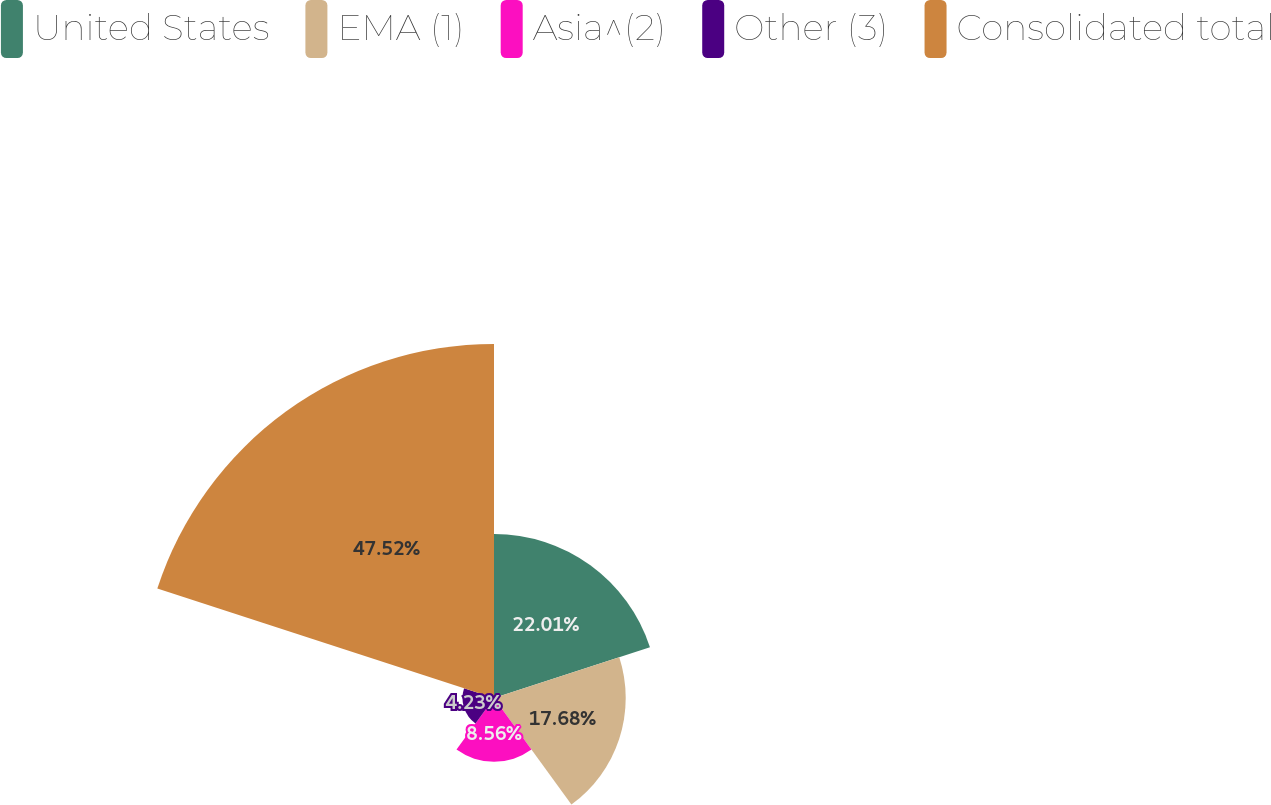<chart> <loc_0><loc_0><loc_500><loc_500><pie_chart><fcel>United States<fcel>EMA (1)<fcel>Asia^(2)<fcel>Other (3)<fcel>Consolidated total<nl><fcel>22.01%<fcel>17.68%<fcel>8.56%<fcel>4.23%<fcel>47.52%<nl></chart> 